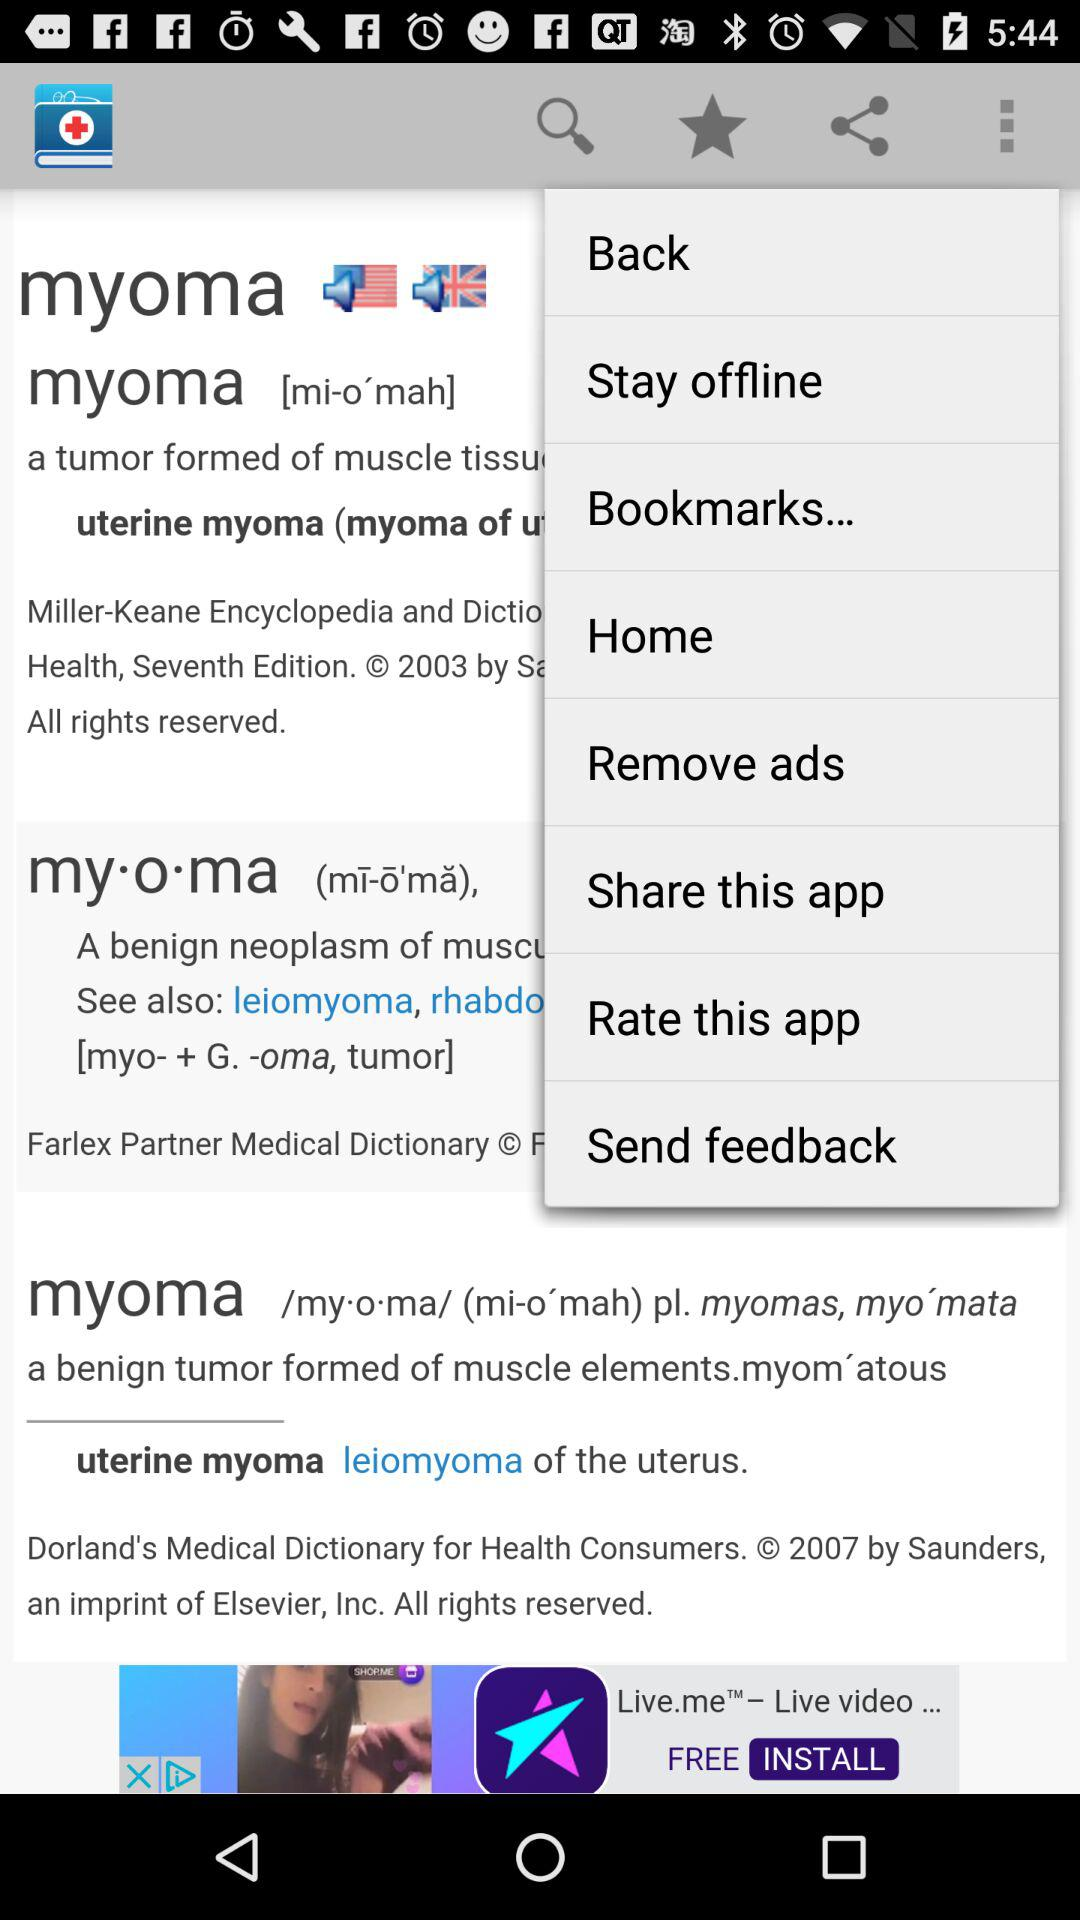Can you tell me more about the application genre or purpose based on the image? The application on the smartphone screen appears to be a medical or health-related dictionary or reference app, as indicated by the definition of medical terms and the presence of options to remove ads and provide feedback, traits commonly found in educational or informational applications. 